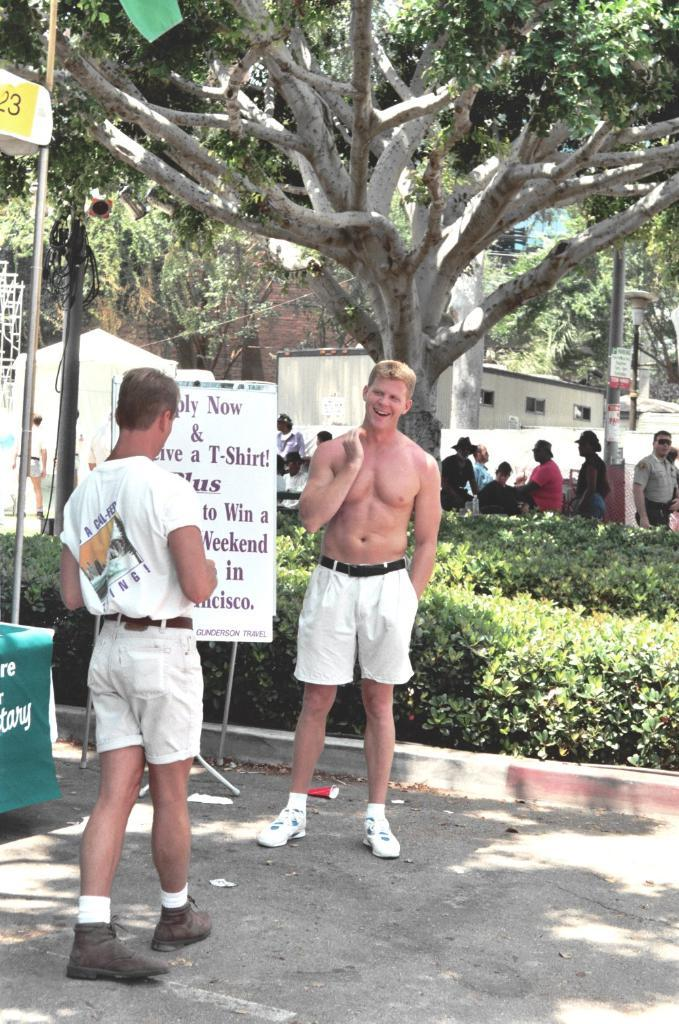<image>
Provide a brief description of the given image. Two men standing in front of a sign that says something about a T-shirt. 